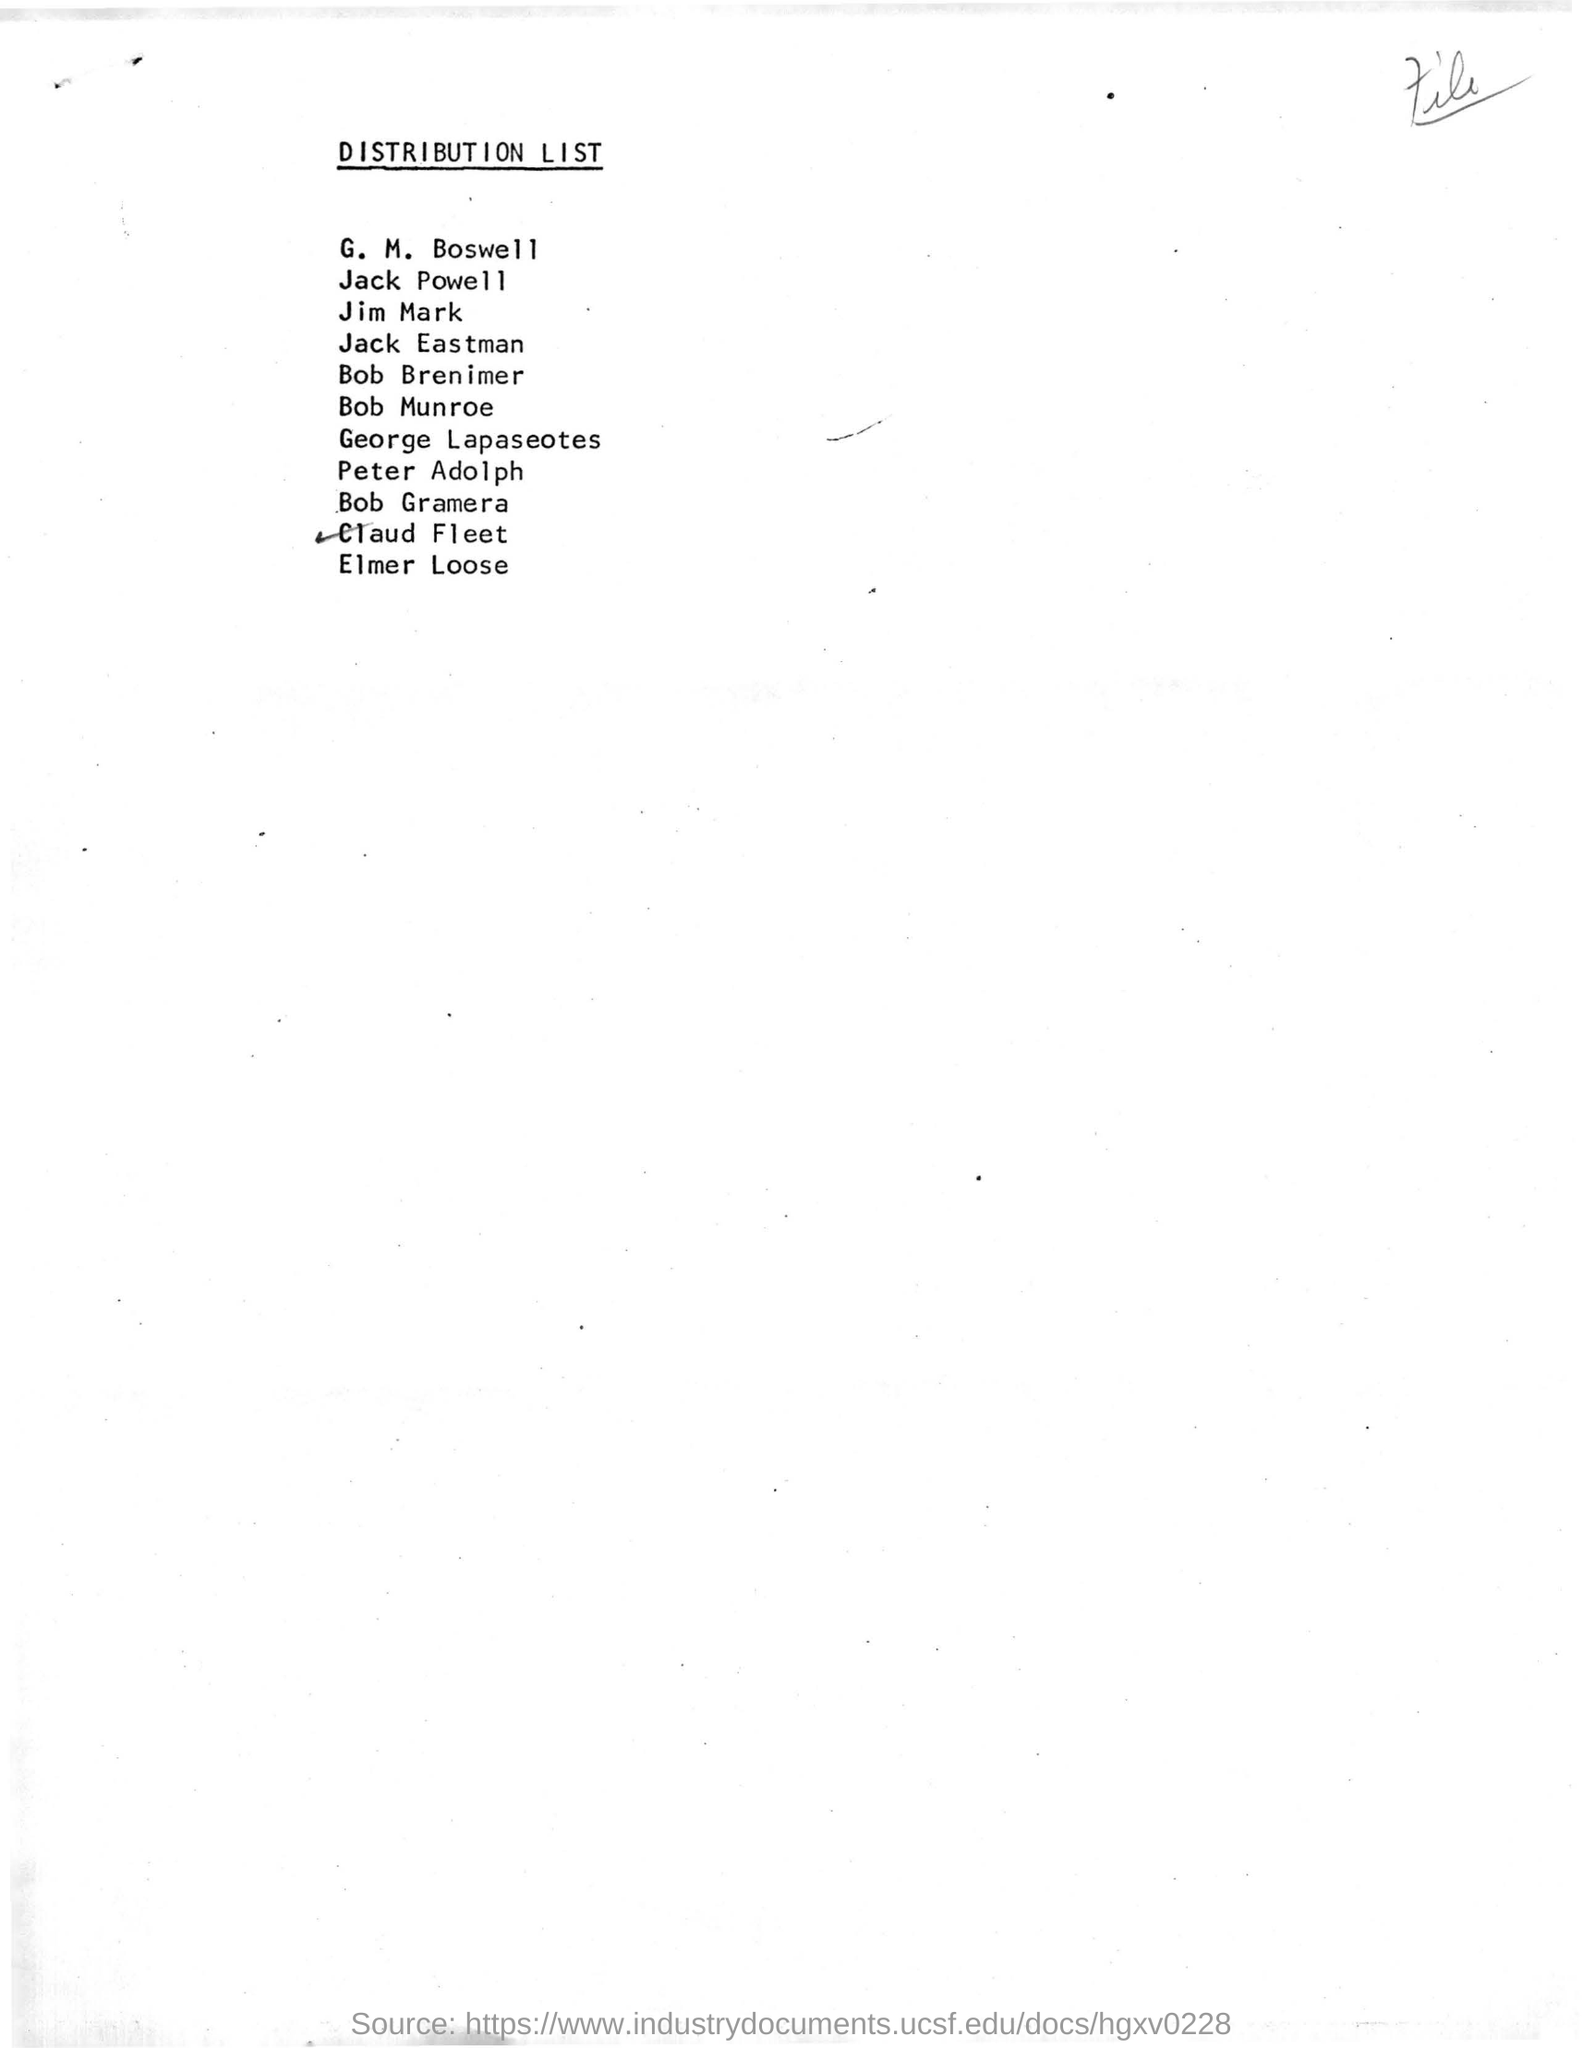Identify some key points in this picture. The title of the document is "Distribution List. The first name in the distribution list is G. M. Boswell. 